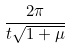<formula> <loc_0><loc_0><loc_500><loc_500>\frac { 2 \pi } { t \sqrt { 1 + \mu } }</formula> 